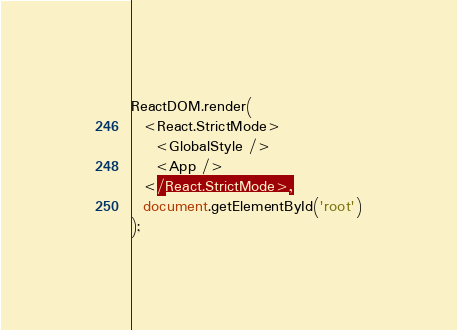<code> <loc_0><loc_0><loc_500><loc_500><_JavaScript_>
ReactDOM.render(
  <React.StrictMode>
    <GlobalStyle />
    <App />
  </React.StrictMode>,
  document.getElementById('root')
);

</code> 